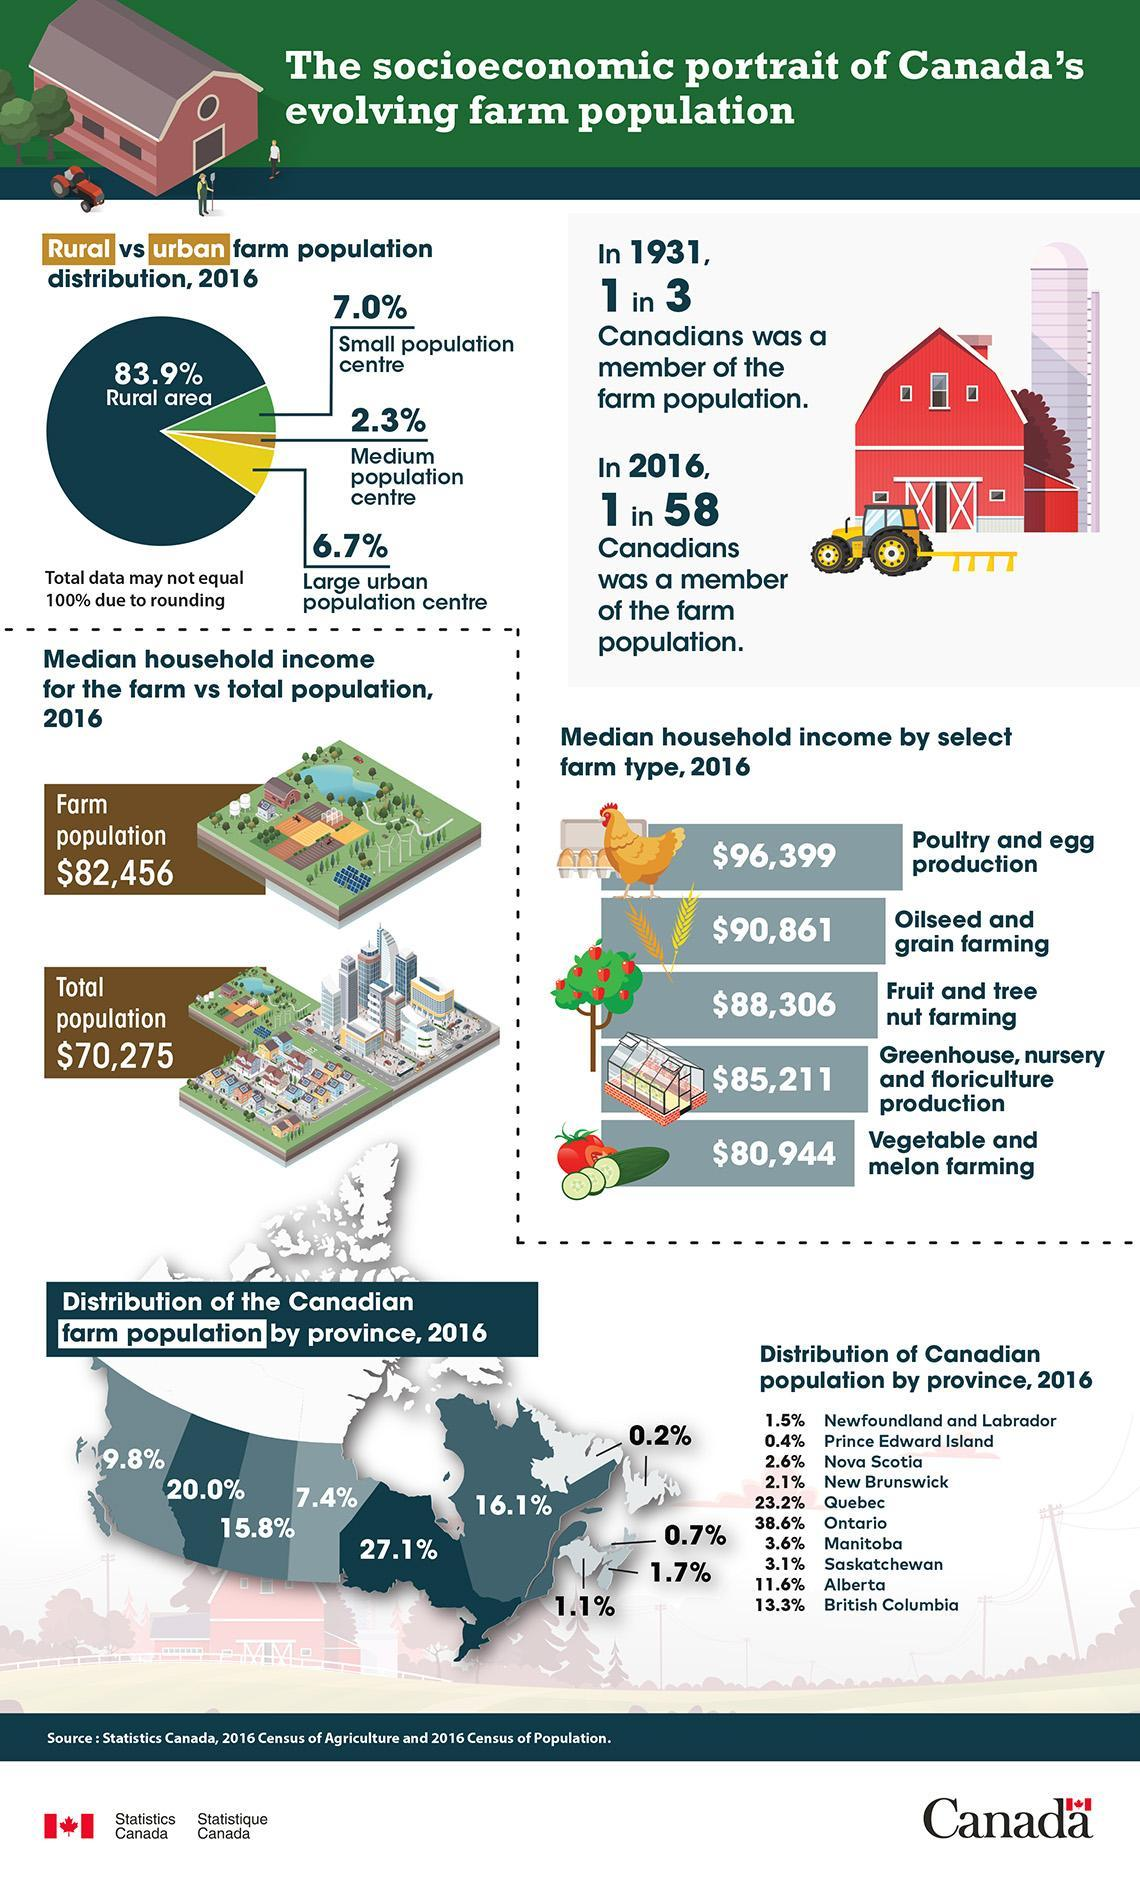During which year was a third of the population involved in farming?
Answer the question with a short phrase. 1931 